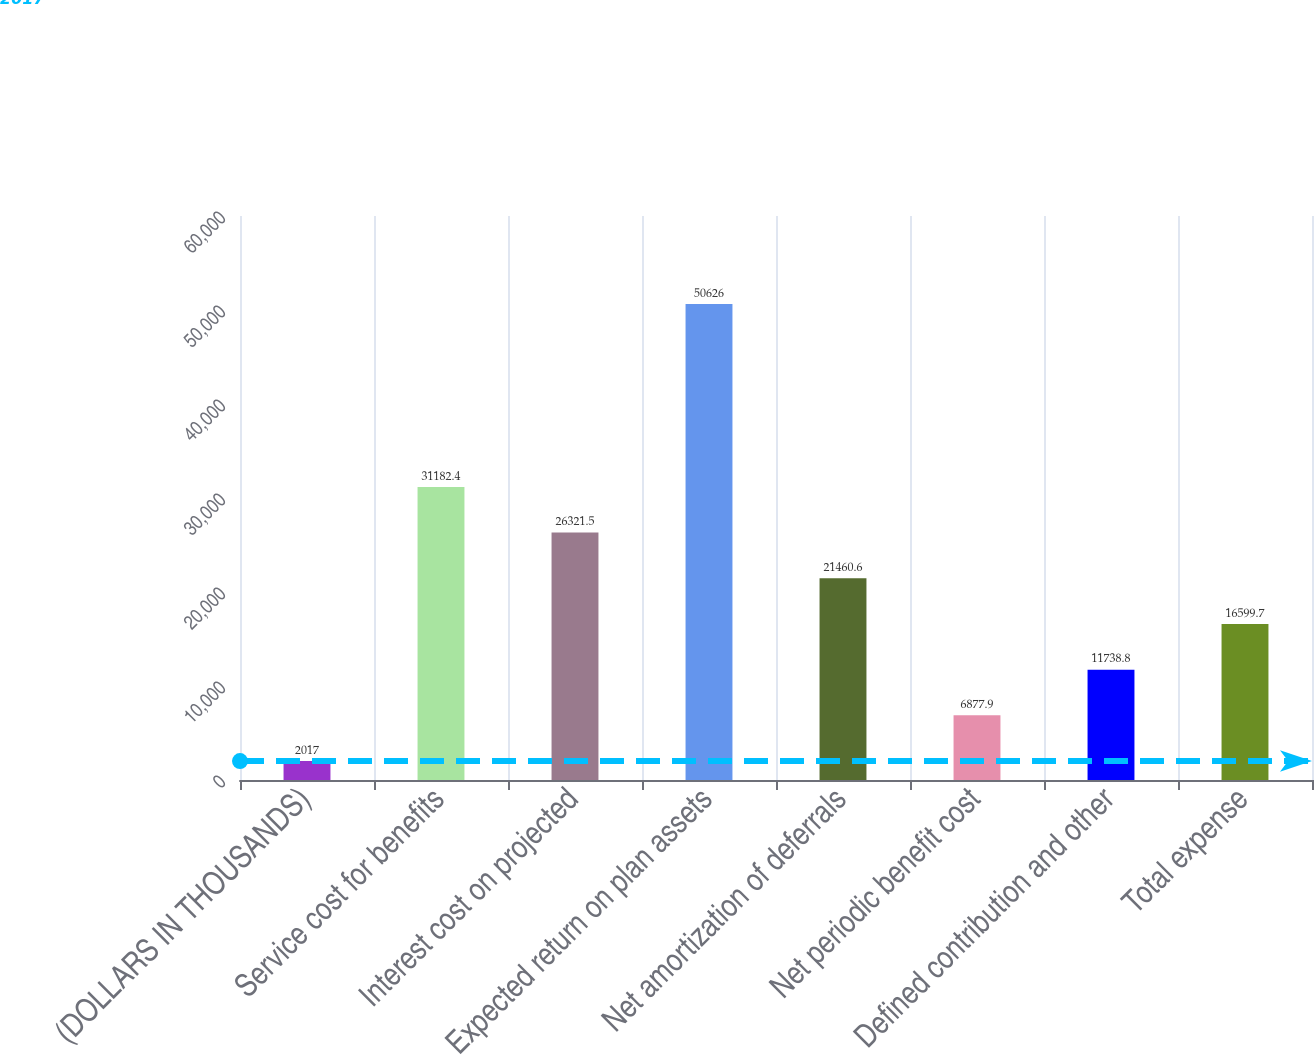<chart> <loc_0><loc_0><loc_500><loc_500><bar_chart><fcel>(DOLLARS IN THOUSANDS)<fcel>Service cost for benefits<fcel>Interest cost on projected<fcel>Expected return on plan assets<fcel>Net amortization of deferrals<fcel>Net periodic benefit cost<fcel>Defined contribution and other<fcel>Total expense<nl><fcel>2017<fcel>31182.4<fcel>26321.5<fcel>50626<fcel>21460.6<fcel>6877.9<fcel>11738.8<fcel>16599.7<nl></chart> 